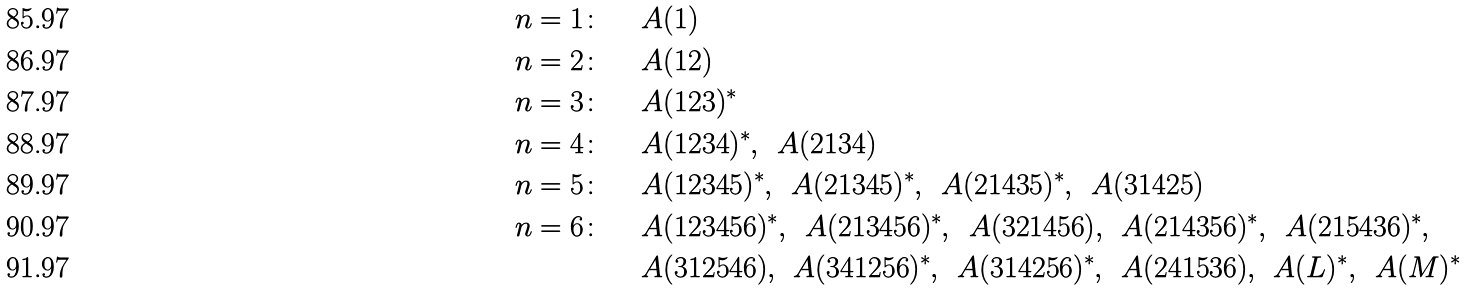<formula> <loc_0><loc_0><loc_500><loc_500>n = 1 \colon & \quad \ A ( 1 ) \\ n = 2 \colon & \quad \ A ( 1 2 ) \\ n = 3 \colon & \quad \ A ( 1 2 3 ) ^ { * } \\ n = 4 \colon & \quad \ A ( 1 2 3 4 ) ^ { * } , \, \ A ( 2 1 3 4 ) \\ n = 5 \colon & \quad \ A ( 1 2 3 4 5 ) ^ { * } , \, \ A ( 2 1 3 4 5 ) ^ { * } , \, \ A ( 2 1 4 3 5 ) ^ { * } , \, \ A ( 3 1 4 2 5 ) \\ n = 6 \colon & \quad \ A ( 1 2 3 4 5 6 ) ^ { * } , \, \ A ( 2 1 3 4 5 6 ) ^ { * } , \, \ A ( 3 2 1 4 5 6 ) , \, \ A ( 2 1 4 3 5 6 ) ^ { * } , \, \ A ( 2 1 5 4 3 6 ) ^ { * } , \\ & \quad \ A ( 3 1 2 5 4 6 ) , \, \ A ( 3 4 1 2 5 6 ) ^ { * } , \, \ A ( 3 1 4 2 5 6 ) ^ { * } , \, \ A ( 2 4 1 5 3 6 ) , \, \ A ( L ) ^ { * } , \, \ A ( M ) ^ { * }</formula> 